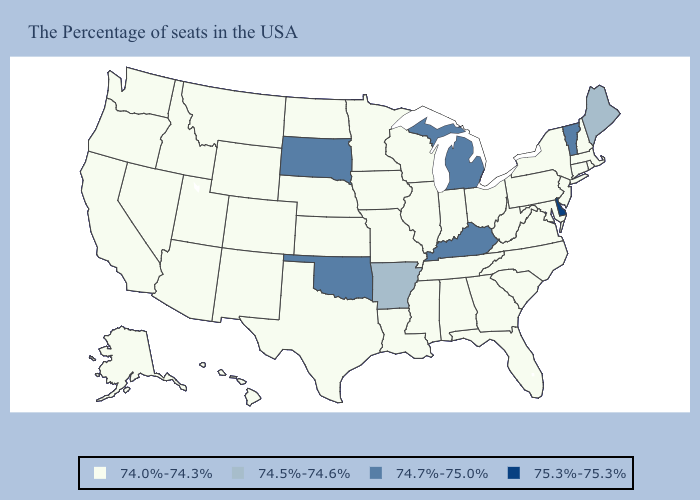Which states hav the highest value in the South?
Keep it brief. Delaware. Name the states that have a value in the range 74.5%-74.6%?
Be succinct. Maine, Arkansas. Does Montana have a lower value than Missouri?
Short answer required. No. Name the states that have a value in the range 75.3%-75.3%?
Concise answer only. Delaware. What is the highest value in states that border Missouri?
Give a very brief answer. 74.7%-75.0%. Among the states that border South Carolina , which have the highest value?
Be succinct. North Carolina, Georgia. Name the states that have a value in the range 74.7%-75.0%?
Give a very brief answer. Vermont, Michigan, Kentucky, Oklahoma, South Dakota. Which states have the highest value in the USA?
Answer briefly. Delaware. Does Virginia have a higher value than Missouri?
Write a very short answer. No. What is the value of Indiana?
Be succinct. 74.0%-74.3%. Name the states that have a value in the range 75.3%-75.3%?
Short answer required. Delaware. What is the value of South Dakota?
Quick response, please. 74.7%-75.0%. Name the states that have a value in the range 74.5%-74.6%?
Concise answer only. Maine, Arkansas. What is the value of Nevada?
Give a very brief answer. 74.0%-74.3%. 